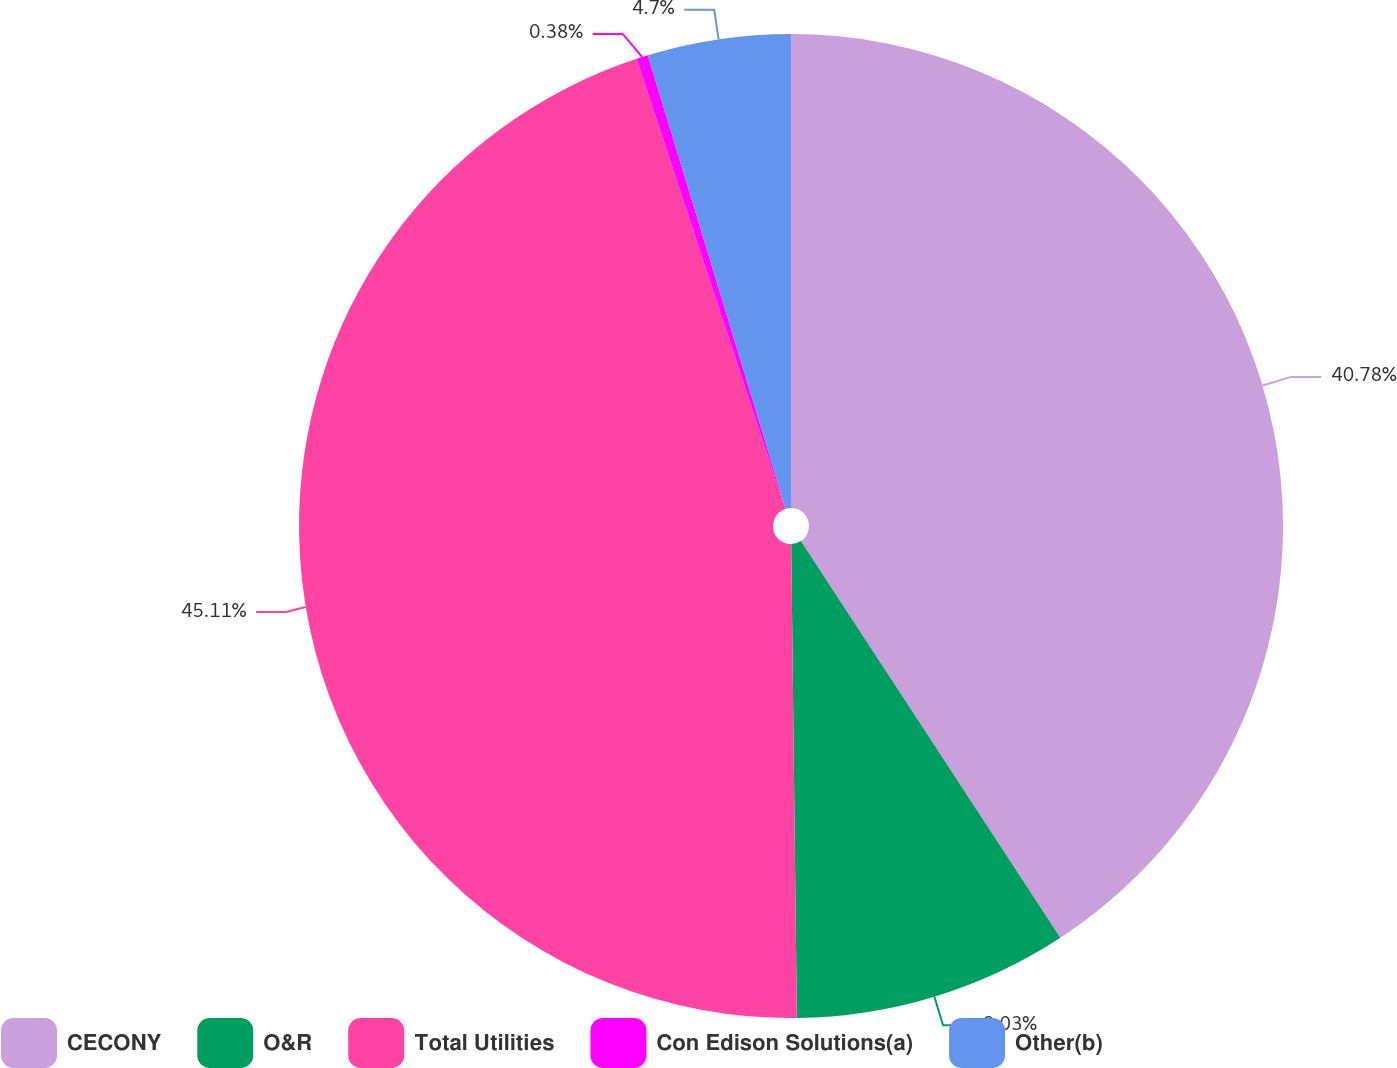Convert chart to OTSL. <chart><loc_0><loc_0><loc_500><loc_500><pie_chart><fcel>CECONY<fcel>O&R<fcel>Total Utilities<fcel>Con Edison Solutions(a)<fcel>Other(b)<nl><fcel>40.78%<fcel>9.03%<fcel>45.11%<fcel>0.38%<fcel>4.7%<nl></chart> 